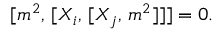Convert formula to latex. <formula><loc_0><loc_0><loc_500><loc_500>{ [ { m ^ { 2 } } , \, [ { X _ { i } } , \, [ { X _ { j } } , \, { m ^ { 2 } } ] ] ] } = 0 .</formula> 